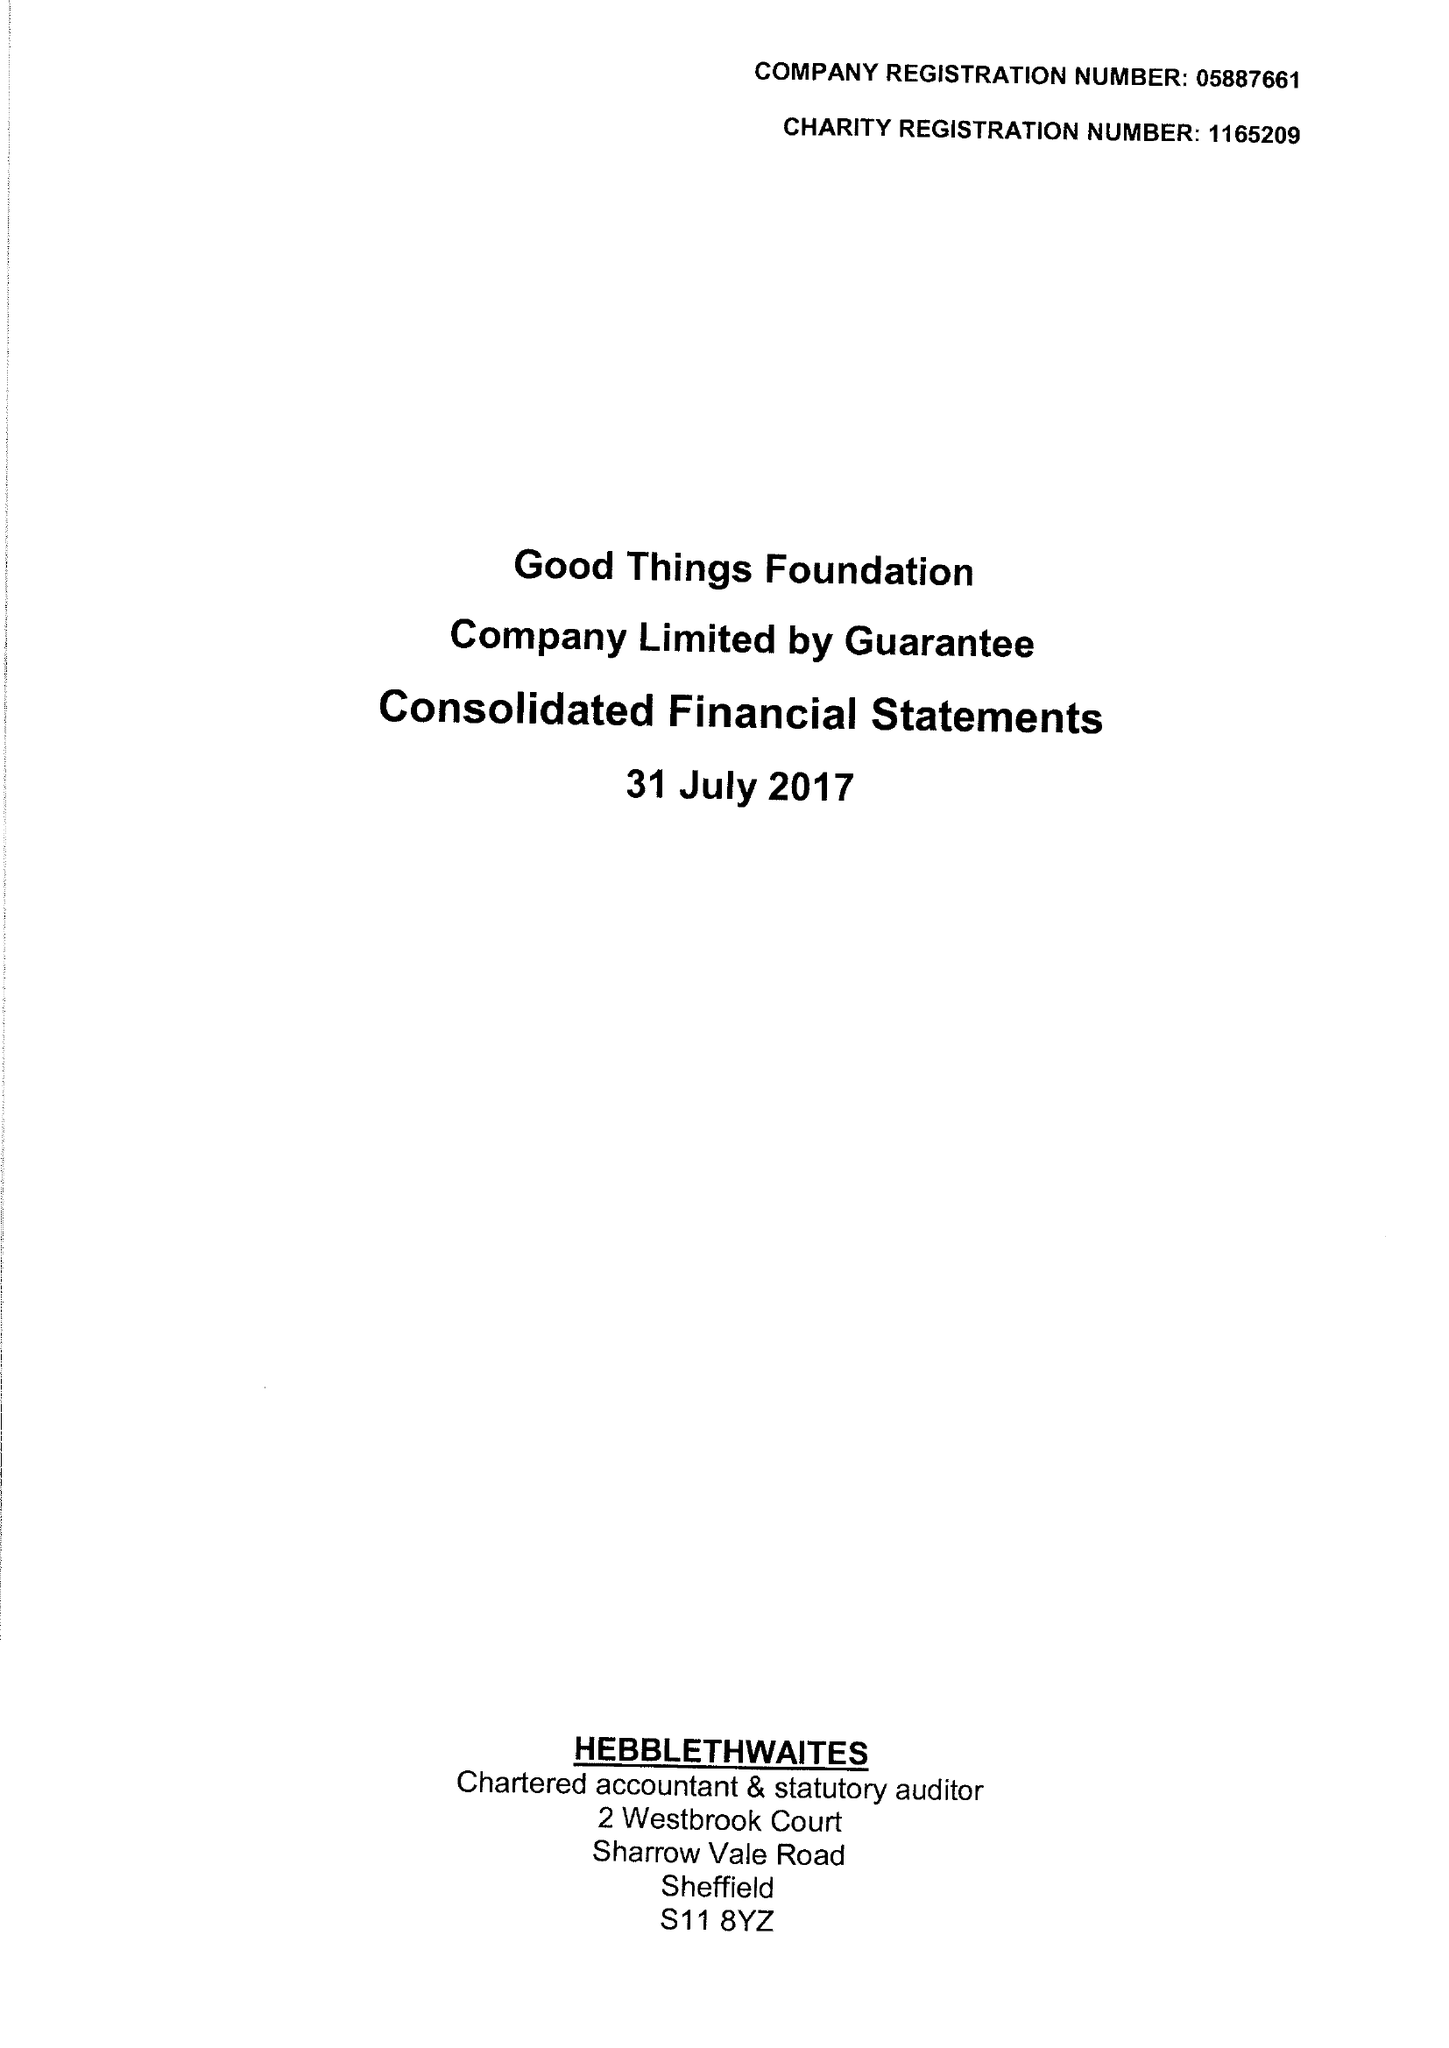What is the value for the address__postcode?
Answer the question using a single word or phrase. S1 2ET 